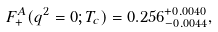Convert formula to latex. <formula><loc_0><loc_0><loc_500><loc_500>F _ { + } ^ { A } ( q ^ { 2 } = 0 ; T _ { c } ) = 0 . 2 5 6 ^ { + 0 . 0 0 4 0 } _ { - 0 . 0 0 4 4 } ,</formula> 